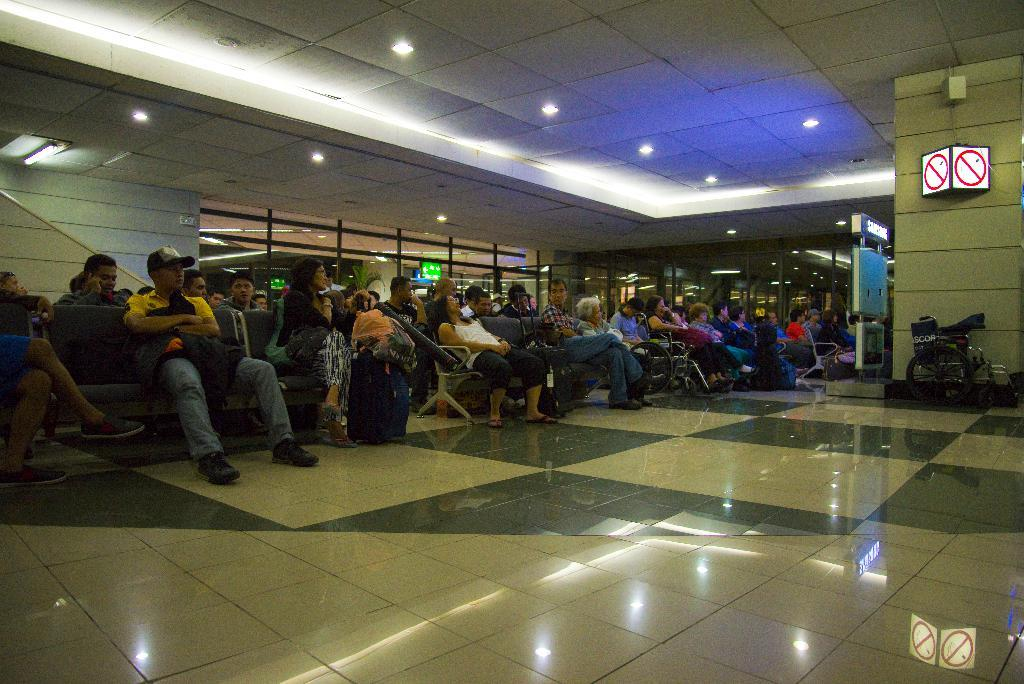What are the people in the room doing? The people in the room are sitting on chairs. What is on the wall in the room? There is a sign board on the wall. What is on the ceiling in the room? There are lights on the ceiling. What type of mobility aid is near the wall? There is a wheelchair near the wall. What is the income of the person sitting on the chair in the image? There is no information about the income of the person sitting on the chair in the image. 